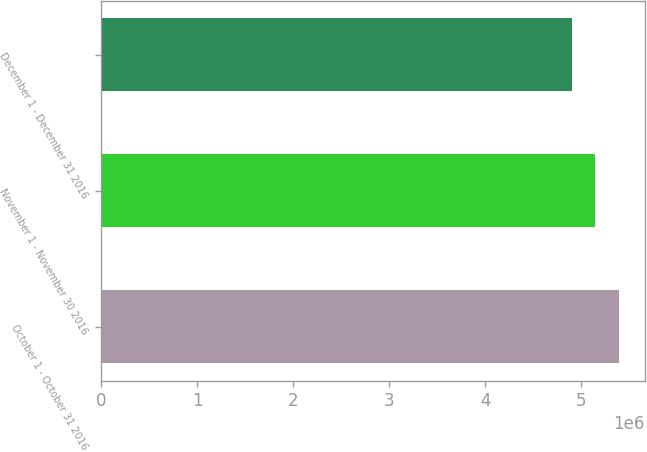Convert chart. <chart><loc_0><loc_0><loc_500><loc_500><bar_chart><fcel>October 1 - October 31 2016<fcel>November 1 - November 30 2016<fcel>December 1 - December 31 2016<nl><fcel>5.39641e+06<fcel>5.1474e+06<fcel>4.9064e+06<nl></chart> 